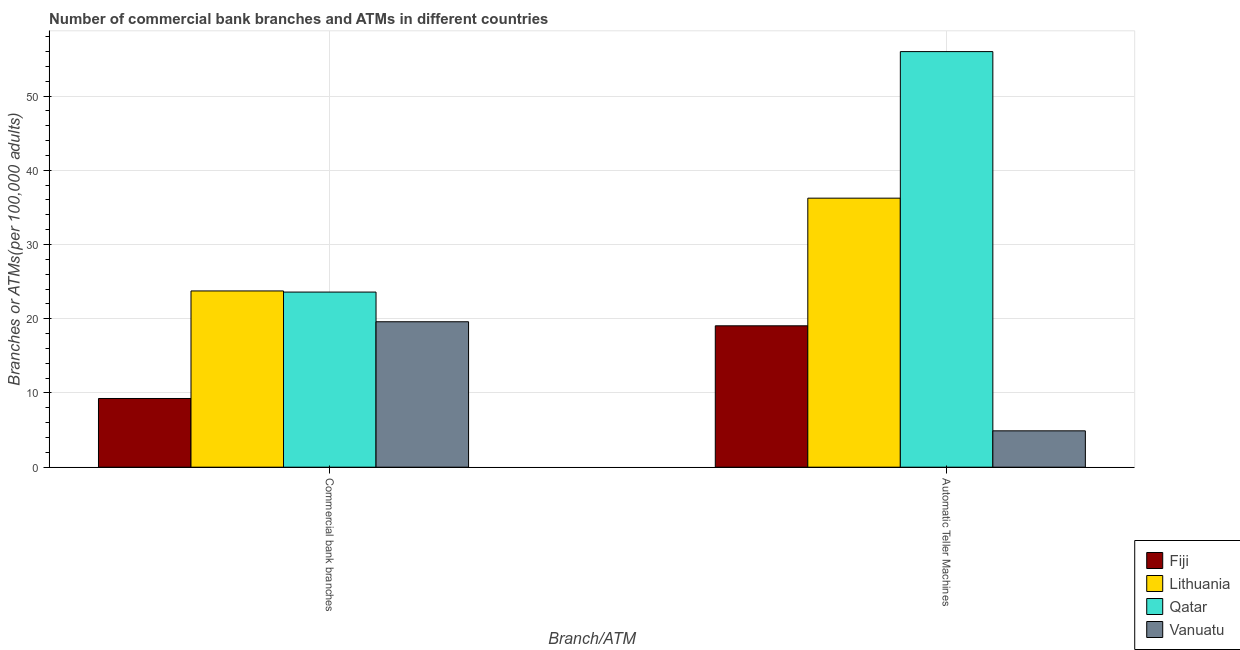How many bars are there on the 1st tick from the right?
Your response must be concise. 4. What is the label of the 1st group of bars from the left?
Keep it short and to the point. Commercial bank branches. What is the number of commercal bank branches in Fiji?
Give a very brief answer. 9.26. Across all countries, what is the maximum number of atms?
Your answer should be compact. 55.99. Across all countries, what is the minimum number of atms?
Offer a terse response. 4.9. In which country was the number of commercal bank branches maximum?
Your response must be concise. Lithuania. In which country was the number of commercal bank branches minimum?
Make the answer very short. Fiji. What is the total number of commercal bank branches in the graph?
Your response must be concise. 76.19. What is the difference between the number of atms in Fiji and that in Vanuatu?
Provide a short and direct response. 14.15. What is the difference between the number of atms in Fiji and the number of commercal bank branches in Qatar?
Offer a very short reply. -4.55. What is the average number of atms per country?
Your response must be concise. 29.04. What is the difference between the number of atms and number of commercal bank branches in Qatar?
Your answer should be very brief. 32.39. What is the ratio of the number of atms in Fiji to that in Qatar?
Make the answer very short. 0.34. Is the number of commercal bank branches in Lithuania less than that in Vanuatu?
Your answer should be very brief. No. In how many countries, is the number of commercal bank branches greater than the average number of commercal bank branches taken over all countries?
Keep it short and to the point. 3. What does the 1st bar from the left in Automatic Teller Machines represents?
Offer a very short reply. Fiji. What does the 2nd bar from the right in Commercial bank branches represents?
Provide a succinct answer. Qatar. What is the difference between two consecutive major ticks on the Y-axis?
Your answer should be very brief. 10. Does the graph contain any zero values?
Offer a terse response. No. How are the legend labels stacked?
Provide a succinct answer. Vertical. What is the title of the graph?
Give a very brief answer. Number of commercial bank branches and ATMs in different countries. What is the label or title of the X-axis?
Your answer should be very brief. Branch/ATM. What is the label or title of the Y-axis?
Provide a short and direct response. Branches or ATMs(per 100,0 adults). What is the Branches or ATMs(per 100,000 adults) of Fiji in Commercial bank branches?
Make the answer very short. 9.26. What is the Branches or ATMs(per 100,000 adults) in Lithuania in Commercial bank branches?
Your answer should be compact. 23.74. What is the Branches or ATMs(per 100,000 adults) in Qatar in Commercial bank branches?
Your answer should be compact. 23.59. What is the Branches or ATMs(per 100,000 adults) of Vanuatu in Commercial bank branches?
Provide a short and direct response. 19.59. What is the Branches or ATMs(per 100,000 adults) of Fiji in Automatic Teller Machines?
Offer a terse response. 19.05. What is the Branches or ATMs(per 100,000 adults) of Lithuania in Automatic Teller Machines?
Give a very brief answer. 36.24. What is the Branches or ATMs(per 100,000 adults) of Qatar in Automatic Teller Machines?
Your answer should be compact. 55.99. What is the Branches or ATMs(per 100,000 adults) in Vanuatu in Automatic Teller Machines?
Provide a short and direct response. 4.9. Across all Branch/ATM, what is the maximum Branches or ATMs(per 100,000 adults) of Fiji?
Give a very brief answer. 19.05. Across all Branch/ATM, what is the maximum Branches or ATMs(per 100,000 adults) in Lithuania?
Ensure brevity in your answer.  36.24. Across all Branch/ATM, what is the maximum Branches or ATMs(per 100,000 adults) of Qatar?
Offer a very short reply. 55.99. Across all Branch/ATM, what is the maximum Branches or ATMs(per 100,000 adults) of Vanuatu?
Offer a very short reply. 19.59. Across all Branch/ATM, what is the minimum Branches or ATMs(per 100,000 adults) of Fiji?
Ensure brevity in your answer.  9.26. Across all Branch/ATM, what is the minimum Branches or ATMs(per 100,000 adults) of Lithuania?
Offer a terse response. 23.74. Across all Branch/ATM, what is the minimum Branches or ATMs(per 100,000 adults) of Qatar?
Provide a succinct answer. 23.59. Across all Branch/ATM, what is the minimum Branches or ATMs(per 100,000 adults) in Vanuatu?
Offer a terse response. 4.9. What is the total Branches or ATMs(per 100,000 adults) of Fiji in the graph?
Your answer should be very brief. 28.3. What is the total Branches or ATMs(per 100,000 adults) in Lithuania in the graph?
Provide a short and direct response. 59.99. What is the total Branches or ATMs(per 100,000 adults) in Qatar in the graph?
Keep it short and to the point. 79.58. What is the total Branches or ATMs(per 100,000 adults) in Vanuatu in the graph?
Provide a short and direct response. 24.49. What is the difference between the Branches or ATMs(per 100,000 adults) in Fiji in Commercial bank branches and that in Automatic Teller Machines?
Your answer should be very brief. -9.79. What is the difference between the Branches or ATMs(per 100,000 adults) in Lithuania in Commercial bank branches and that in Automatic Teller Machines?
Make the answer very short. -12.5. What is the difference between the Branches or ATMs(per 100,000 adults) of Qatar in Commercial bank branches and that in Automatic Teller Machines?
Ensure brevity in your answer.  -32.39. What is the difference between the Branches or ATMs(per 100,000 adults) of Vanuatu in Commercial bank branches and that in Automatic Teller Machines?
Make the answer very short. 14.7. What is the difference between the Branches or ATMs(per 100,000 adults) in Fiji in Commercial bank branches and the Branches or ATMs(per 100,000 adults) in Lithuania in Automatic Teller Machines?
Offer a very short reply. -26.99. What is the difference between the Branches or ATMs(per 100,000 adults) of Fiji in Commercial bank branches and the Branches or ATMs(per 100,000 adults) of Qatar in Automatic Teller Machines?
Provide a short and direct response. -46.73. What is the difference between the Branches or ATMs(per 100,000 adults) of Fiji in Commercial bank branches and the Branches or ATMs(per 100,000 adults) of Vanuatu in Automatic Teller Machines?
Offer a very short reply. 4.36. What is the difference between the Branches or ATMs(per 100,000 adults) in Lithuania in Commercial bank branches and the Branches or ATMs(per 100,000 adults) in Qatar in Automatic Teller Machines?
Provide a succinct answer. -32.24. What is the difference between the Branches or ATMs(per 100,000 adults) of Lithuania in Commercial bank branches and the Branches or ATMs(per 100,000 adults) of Vanuatu in Automatic Teller Machines?
Offer a terse response. 18.85. What is the difference between the Branches or ATMs(per 100,000 adults) in Qatar in Commercial bank branches and the Branches or ATMs(per 100,000 adults) in Vanuatu in Automatic Teller Machines?
Offer a very short reply. 18.69. What is the average Branches or ATMs(per 100,000 adults) in Fiji per Branch/ATM?
Provide a short and direct response. 14.15. What is the average Branches or ATMs(per 100,000 adults) of Lithuania per Branch/ATM?
Provide a short and direct response. 29.99. What is the average Branches or ATMs(per 100,000 adults) of Qatar per Branch/ATM?
Your answer should be very brief. 39.79. What is the average Branches or ATMs(per 100,000 adults) in Vanuatu per Branch/ATM?
Provide a short and direct response. 12.25. What is the difference between the Branches or ATMs(per 100,000 adults) in Fiji and Branches or ATMs(per 100,000 adults) in Lithuania in Commercial bank branches?
Keep it short and to the point. -14.49. What is the difference between the Branches or ATMs(per 100,000 adults) in Fiji and Branches or ATMs(per 100,000 adults) in Qatar in Commercial bank branches?
Your response must be concise. -14.34. What is the difference between the Branches or ATMs(per 100,000 adults) of Fiji and Branches or ATMs(per 100,000 adults) of Vanuatu in Commercial bank branches?
Provide a succinct answer. -10.34. What is the difference between the Branches or ATMs(per 100,000 adults) of Lithuania and Branches or ATMs(per 100,000 adults) of Qatar in Commercial bank branches?
Provide a succinct answer. 0.15. What is the difference between the Branches or ATMs(per 100,000 adults) of Lithuania and Branches or ATMs(per 100,000 adults) of Vanuatu in Commercial bank branches?
Offer a very short reply. 4.15. What is the difference between the Branches or ATMs(per 100,000 adults) in Qatar and Branches or ATMs(per 100,000 adults) in Vanuatu in Commercial bank branches?
Make the answer very short. 4. What is the difference between the Branches or ATMs(per 100,000 adults) in Fiji and Branches or ATMs(per 100,000 adults) in Lithuania in Automatic Teller Machines?
Give a very brief answer. -17.2. What is the difference between the Branches or ATMs(per 100,000 adults) of Fiji and Branches or ATMs(per 100,000 adults) of Qatar in Automatic Teller Machines?
Your answer should be very brief. -36.94. What is the difference between the Branches or ATMs(per 100,000 adults) of Fiji and Branches or ATMs(per 100,000 adults) of Vanuatu in Automatic Teller Machines?
Give a very brief answer. 14.15. What is the difference between the Branches or ATMs(per 100,000 adults) of Lithuania and Branches or ATMs(per 100,000 adults) of Qatar in Automatic Teller Machines?
Make the answer very short. -19.74. What is the difference between the Branches or ATMs(per 100,000 adults) of Lithuania and Branches or ATMs(per 100,000 adults) of Vanuatu in Automatic Teller Machines?
Provide a succinct answer. 31.34. What is the difference between the Branches or ATMs(per 100,000 adults) in Qatar and Branches or ATMs(per 100,000 adults) in Vanuatu in Automatic Teller Machines?
Provide a short and direct response. 51.09. What is the ratio of the Branches or ATMs(per 100,000 adults) of Fiji in Commercial bank branches to that in Automatic Teller Machines?
Give a very brief answer. 0.49. What is the ratio of the Branches or ATMs(per 100,000 adults) of Lithuania in Commercial bank branches to that in Automatic Teller Machines?
Your answer should be compact. 0.66. What is the ratio of the Branches or ATMs(per 100,000 adults) of Qatar in Commercial bank branches to that in Automatic Teller Machines?
Your answer should be compact. 0.42. What is the ratio of the Branches or ATMs(per 100,000 adults) in Vanuatu in Commercial bank branches to that in Automatic Teller Machines?
Keep it short and to the point. 4. What is the difference between the highest and the second highest Branches or ATMs(per 100,000 adults) of Fiji?
Give a very brief answer. 9.79. What is the difference between the highest and the second highest Branches or ATMs(per 100,000 adults) of Lithuania?
Provide a succinct answer. 12.5. What is the difference between the highest and the second highest Branches or ATMs(per 100,000 adults) of Qatar?
Your answer should be compact. 32.39. What is the difference between the highest and the second highest Branches or ATMs(per 100,000 adults) in Vanuatu?
Keep it short and to the point. 14.7. What is the difference between the highest and the lowest Branches or ATMs(per 100,000 adults) in Fiji?
Provide a short and direct response. 9.79. What is the difference between the highest and the lowest Branches or ATMs(per 100,000 adults) of Lithuania?
Your answer should be very brief. 12.5. What is the difference between the highest and the lowest Branches or ATMs(per 100,000 adults) in Qatar?
Provide a short and direct response. 32.39. What is the difference between the highest and the lowest Branches or ATMs(per 100,000 adults) in Vanuatu?
Your response must be concise. 14.7. 